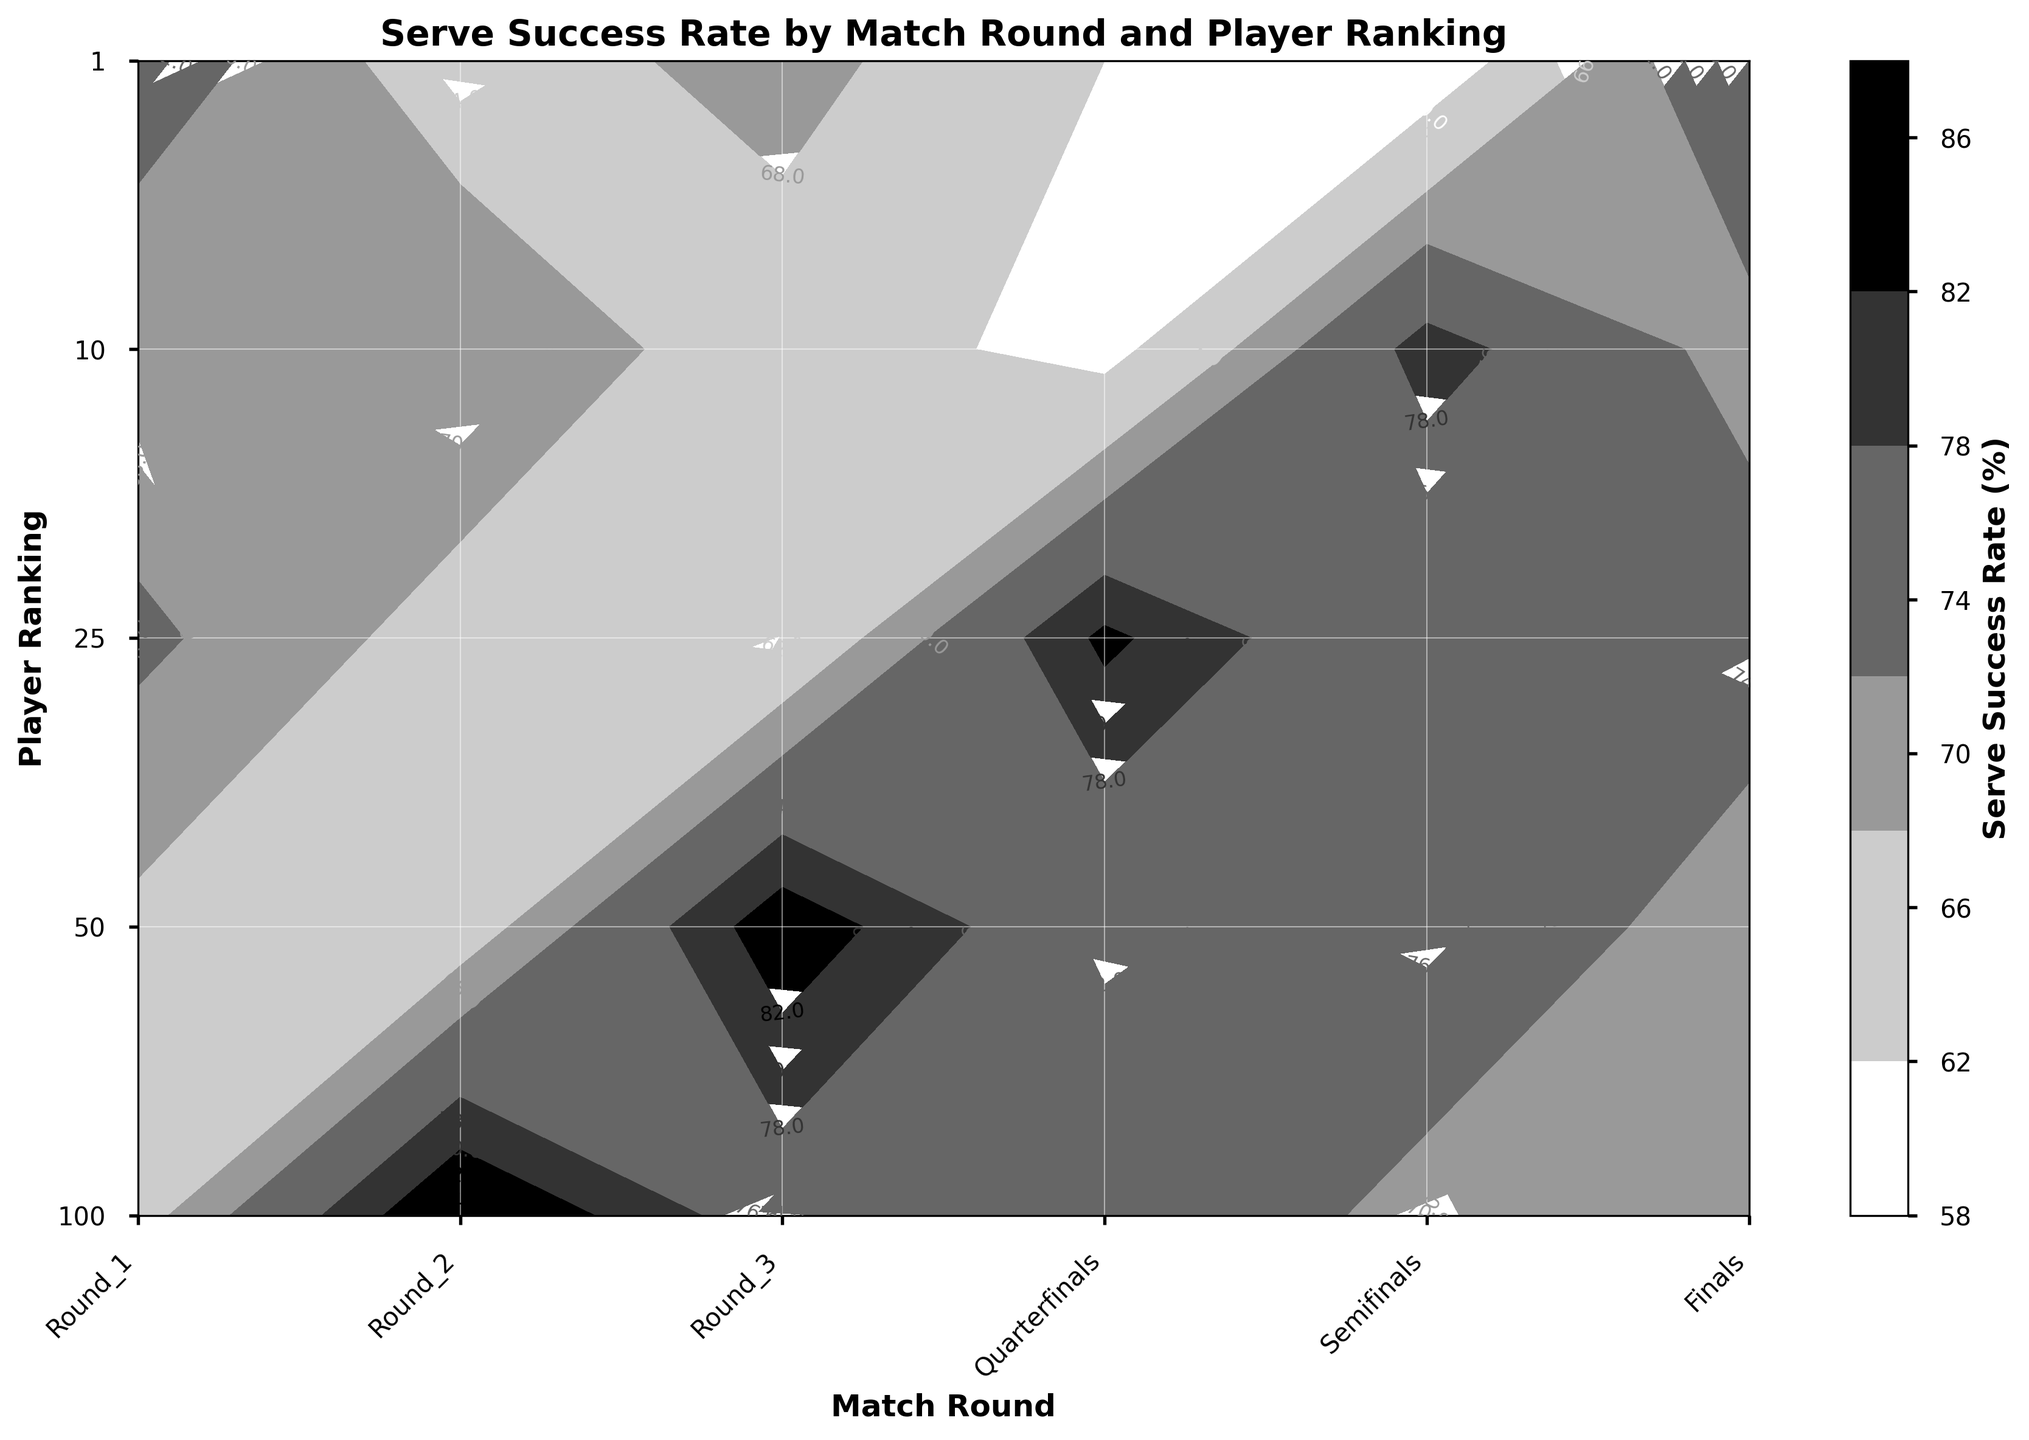What is the title of the figure? The title of the figure is usually placed at the top center to provide a summary of the figure’s content.
Answer: Serve Success Rate by Match Round and Player Ranking What is the label of the x-axis? The x-axis label is clearly written below the x-axis and should indicate what is displayed on the x-axis.
Answer: Match Round Which player ranking has the highest serve success rate in the finals? Locate the finals on the x-axis, then find the highest contour level or value on the y-axis indicating player rankings.
Answer: 1 How does the serve success rate change for the top-ranked player from Round 1 to the Finals? Follow the contour line or values corresponding to the top-ranked player (ranking 1) across the rounds from Round 1 to Finals.
Answer: It increases Between which match rounds does the 25th ranked player see the biggest increase in serve success rate? Compare the serve success rate between each consecutive round for the player ranked 25. The biggest increase will be where the difference is largest.
Answer: Semifinals to Finals What is the serve success rate for the 50th ranked player in the Semifinals? Locate the Semifinals on the x-axis, and then follow up to the contour level at the 50th player ranking on the y-axis.
Answer: 69% Compare the serve success rates of players ranked 10 and 25 in the Quarterfinals. Check the contour levels or values for players ranked 10 and 25 in the Quarterfinals on the figure.
Answer: 72% and 75% What pattern is observed in serve success rates across different match rounds, regardless of player ranking? Examine the overall trend from Round 1 to Finals across all player rankings to identify common patterns.
Answer: Serve success rates generally increase During which match round is the serve success rate for the player ranked 100 the lowest? Compare the serve success rates of the player ranked 100 across all match rounds and identify the lowest value.
Answer: Round 1 